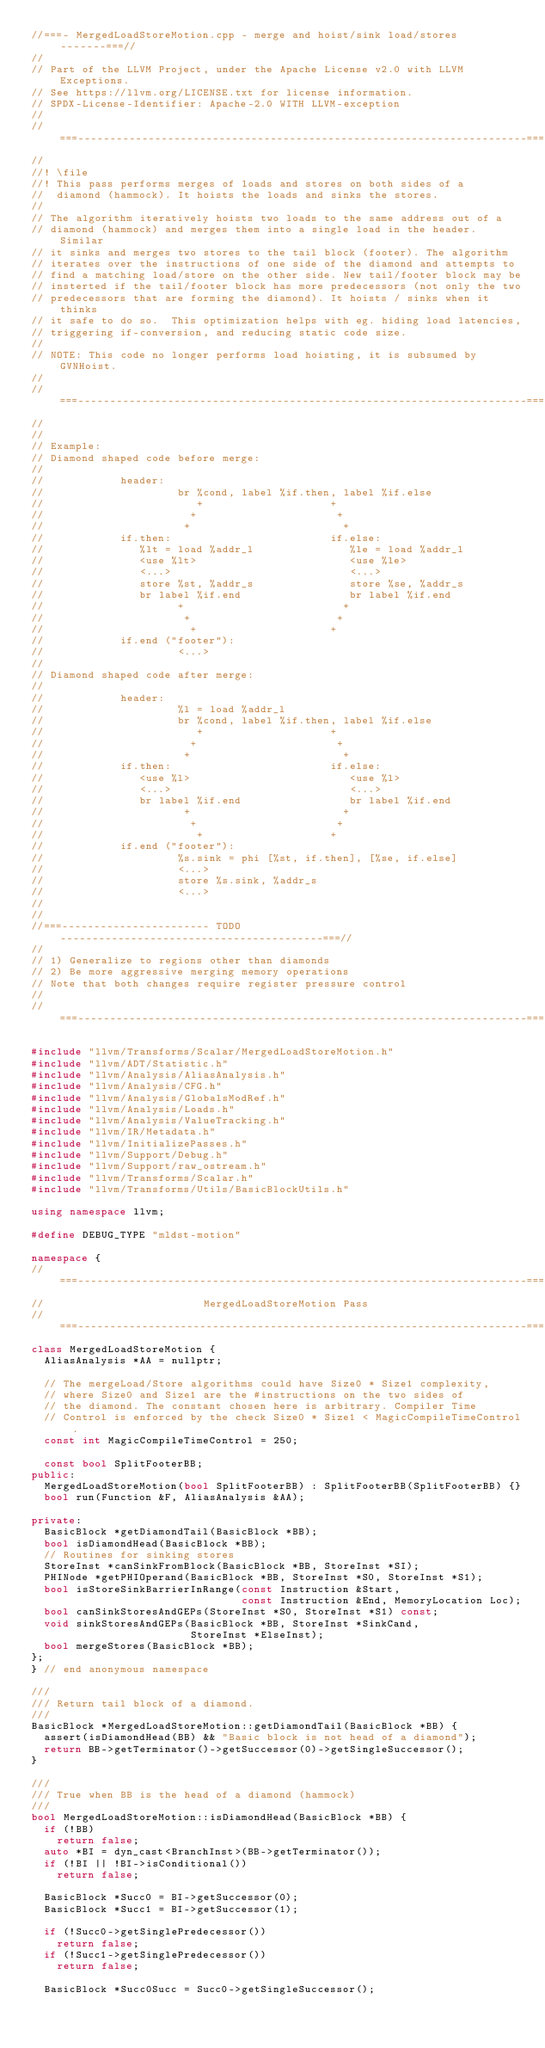Convert code to text. <code><loc_0><loc_0><loc_500><loc_500><_C++_>//===- MergedLoadStoreMotion.cpp - merge and hoist/sink load/stores -------===//
//
// Part of the LLVM Project, under the Apache License v2.0 with LLVM Exceptions.
// See https://llvm.org/LICENSE.txt for license information.
// SPDX-License-Identifier: Apache-2.0 WITH LLVM-exception
//
//===----------------------------------------------------------------------===//
//
//! \file
//! This pass performs merges of loads and stores on both sides of a
//  diamond (hammock). It hoists the loads and sinks the stores.
//
// The algorithm iteratively hoists two loads to the same address out of a
// diamond (hammock) and merges them into a single load in the header. Similar
// it sinks and merges two stores to the tail block (footer). The algorithm
// iterates over the instructions of one side of the diamond and attempts to
// find a matching load/store on the other side. New tail/footer block may be
// insterted if the tail/footer block has more predecessors (not only the two
// predecessors that are forming the diamond). It hoists / sinks when it thinks
// it safe to do so.  This optimization helps with eg. hiding load latencies,
// triggering if-conversion, and reducing static code size.
//
// NOTE: This code no longer performs load hoisting, it is subsumed by GVNHoist.
//
//===----------------------------------------------------------------------===//
//
//
// Example:
// Diamond shaped code before merge:
//
//            header:
//                     br %cond, label %if.then, label %if.else
//                        +                    +
//                       +                      +
//                      +                        +
//            if.then:                         if.else:
//               %lt = load %addr_l               %le = load %addr_l
//               <use %lt>                        <use %le>
//               <...>                            <...>
//               store %st, %addr_s               store %se, %addr_s
//               br label %if.end                 br label %if.end
//                     +                         +
//                      +                       +
//                       +                     +
//            if.end ("footer"):
//                     <...>
//
// Diamond shaped code after merge:
//
//            header:
//                     %l = load %addr_l
//                     br %cond, label %if.then, label %if.else
//                        +                    +
//                       +                      +
//                      +                        +
//            if.then:                         if.else:
//               <use %l>                         <use %l>
//               <...>                            <...>
//               br label %if.end                 br label %if.end
//                      +                        +
//                       +                      +
//                        +                    +
//            if.end ("footer"):
//                     %s.sink = phi [%st, if.then], [%se, if.else]
//                     <...>
//                     store %s.sink, %addr_s
//                     <...>
//
//
//===----------------------- TODO -----------------------------------------===//
//
// 1) Generalize to regions other than diamonds
// 2) Be more aggressive merging memory operations
// Note that both changes require register pressure control
//
//===----------------------------------------------------------------------===//

#include "llvm/Transforms/Scalar/MergedLoadStoreMotion.h"
#include "llvm/ADT/Statistic.h"
#include "llvm/Analysis/AliasAnalysis.h"
#include "llvm/Analysis/CFG.h"
#include "llvm/Analysis/GlobalsModRef.h"
#include "llvm/Analysis/Loads.h"
#include "llvm/Analysis/ValueTracking.h"
#include "llvm/IR/Metadata.h"
#include "llvm/InitializePasses.h"
#include "llvm/Support/Debug.h"
#include "llvm/Support/raw_ostream.h"
#include "llvm/Transforms/Scalar.h"
#include "llvm/Transforms/Utils/BasicBlockUtils.h"

using namespace llvm;

#define DEBUG_TYPE "mldst-motion"

namespace {
//===----------------------------------------------------------------------===//
//                         MergedLoadStoreMotion Pass
//===----------------------------------------------------------------------===//
class MergedLoadStoreMotion {
  AliasAnalysis *AA = nullptr;

  // The mergeLoad/Store algorithms could have Size0 * Size1 complexity,
  // where Size0 and Size1 are the #instructions on the two sides of
  // the diamond. The constant chosen here is arbitrary. Compiler Time
  // Control is enforced by the check Size0 * Size1 < MagicCompileTimeControl.
  const int MagicCompileTimeControl = 250;

  const bool SplitFooterBB;
public:
  MergedLoadStoreMotion(bool SplitFooterBB) : SplitFooterBB(SplitFooterBB) {}
  bool run(Function &F, AliasAnalysis &AA);

private:
  BasicBlock *getDiamondTail(BasicBlock *BB);
  bool isDiamondHead(BasicBlock *BB);
  // Routines for sinking stores
  StoreInst *canSinkFromBlock(BasicBlock *BB, StoreInst *SI);
  PHINode *getPHIOperand(BasicBlock *BB, StoreInst *S0, StoreInst *S1);
  bool isStoreSinkBarrierInRange(const Instruction &Start,
                                 const Instruction &End, MemoryLocation Loc);
  bool canSinkStoresAndGEPs(StoreInst *S0, StoreInst *S1) const;
  void sinkStoresAndGEPs(BasicBlock *BB, StoreInst *SinkCand,
                         StoreInst *ElseInst);
  bool mergeStores(BasicBlock *BB);
};
} // end anonymous namespace

///
/// Return tail block of a diamond.
///
BasicBlock *MergedLoadStoreMotion::getDiamondTail(BasicBlock *BB) {
  assert(isDiamondHead(BB) && "Basic block is not head of a diamond");
  return BB->getTerminator()->getSuccessor(0)->getSingleSuccessor();
}

///
/// True when BB is the head of a diamond (hammock)
///
bool MergedLoadStoreMotion::isDiamondHead(BasicBlock *BB) {
  if (!BB)
    return false;
  auto *BI = dyn_cast<BranchInst>(BB->getTerminator());
  if (!BI || !BI->isConditional())
    return false;

  BasicBlock *Succ0 = BI->getSuccessor(0);
  BasicBlock *Succ1 = BI->getSuccessor(1);

  if (!Succ0->getSinglePredecessor())
    return false;
  if (!Succ1->getSinglePredecessor())
    return false;

  BasicBlock *Succ0Succ = Succ0->getSingleSuccessor();</code> 